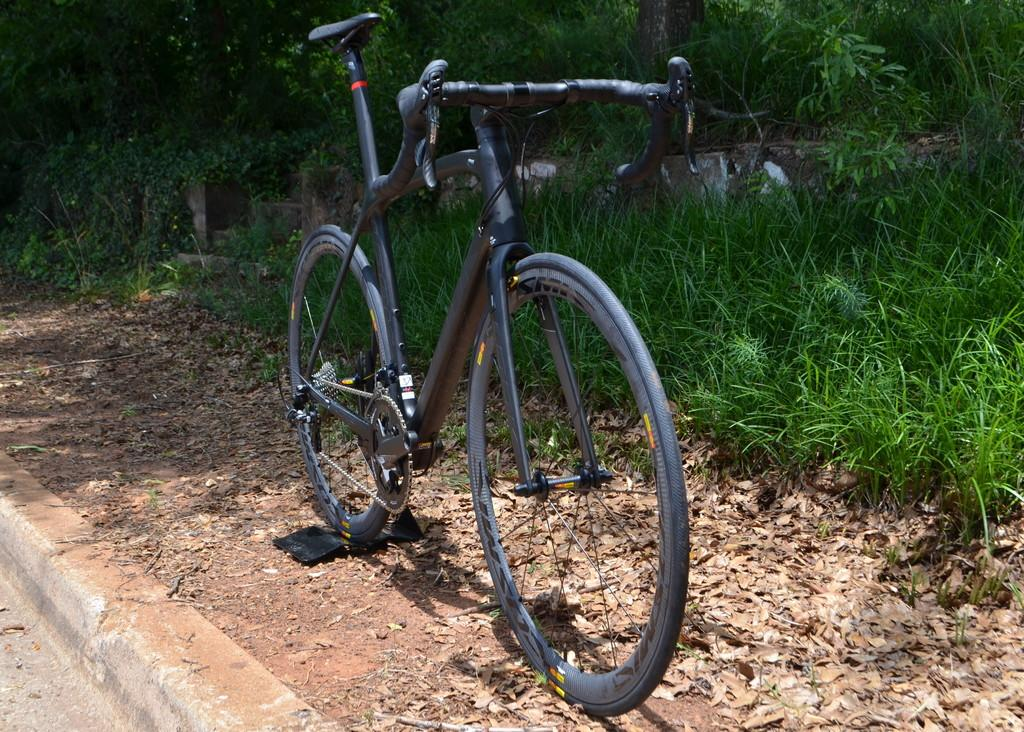What is the main object in the image? There is a bicycle in the image. What can be seen in the background of the image? There is grass and trees in the background of the image. What type of cat can be seen riding the bicycle in the image? There is no cat present in the image, and the bicycle is not being ridden by any animal or person. 